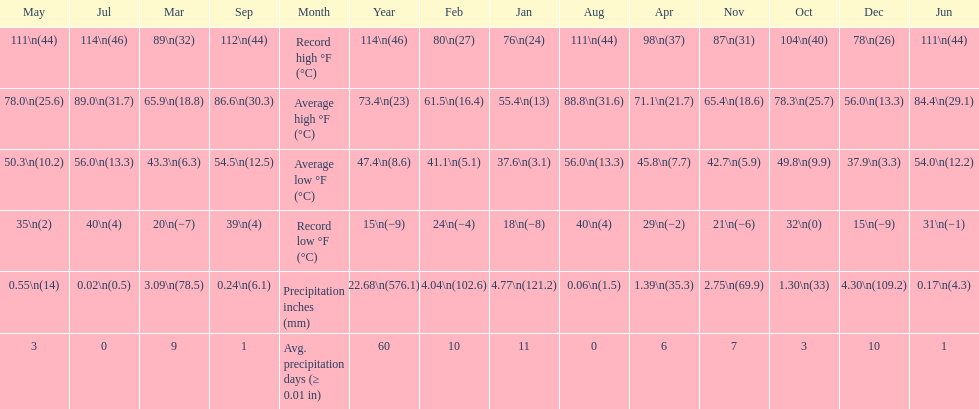Which month had an average high of 89.0 degrees and an average low of 56.0 degrees? July. Would you mind parsing the complete table? {'header': ['May', 'Jul', 'Mar', 'Sep', 'Month', 'Year', 'Feb', 'Jan', 'Aug', 'Apr', 'Nov', 'Oct', 'Dec', 'Jun'], 'rows': [['111\\n(44)', '114\\n(46)', '89\\n(32)', '112\\n(44)', 'Record high °F (°C)', '114\\n(46)', '80\\n(27)', '76\\n(24)', '111\\n(44)', '98\\n(37)', '87\\n(31)', '104\\n(40)', '78\\n(26)', '111\\n(44)'], ['78.0\\n(25.6)', '89.0\\n(31.7)', '65.9\\n(18.8)', '86.6\\n(30.3)', 'Average high °F (°C)', '73.4\\n(23)', '61.5\\n(16.4)', '55.4\\n(13)', '88.8\\n(31.6)', '71.1\\n(21.7)', '65.4\\n(18.6)', '78.3\\n(25.7)', '56.0\\n(13.3)', '84.4\\n(29.1)'], ['50.3\\n(10.2)', '56.0\\n(13.3)', '43.3\\n(6.3)', '54.5\\n(12.5)', 'Average low °F (°C)', '47.4\\n(8.6)', '41.1\\n(5.1)', '37.6\\n(3.1)', '56.0\\n(13.3)', '45.8\\n(7.7)', '42.7\\n(5.9)', '49.8\\n(9.9)', '37.9\\n(3.3)', '54.0\\n(12.2)'], ['35\\n(2)', '40\\n(4)', '20\\n(−7)', '39\\n(4)', 'Record low °F (°C)', '15\\n(−9)', '24\\n(−4)', '18\\n(−8)', '40\\n(4)', '29\\n(−2)', '21\\n(−6)', '32\\n(0)', '15\\n(−9)', '31\\n(−1)'], ['0.55\\n(14)', '0.02\\n(0.5)', '3.09\\n(78.5)', '0.24\\n(6.1)', 'Precipitation inches (mm)', '22.68\\n(576.1)', '4.04\\n(102.6)', '4.77\\n(121.2)', '0.06\\n(1.5)', '1.39\\n(35.3)', '2.75\\n(69.9)', '1.30\\n(33)', '4.30\\n(109.2)', '0.17\\n(4.3)'], ['3', '0', '9', '1', 'Avg. precipitation days (≥ 0.01 in)', '60', '10', '11', '0', '6', '7', '3', '10', '1']]} 